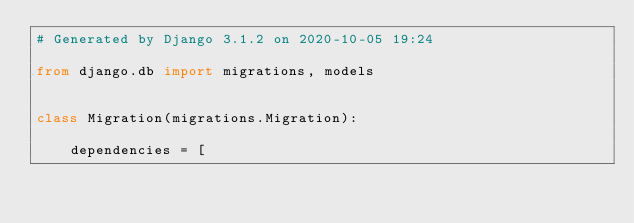Convert code to text. <code><loc_0><loc_0><loc_500><loc_500><_Python_># Generated by Django 3.1.2 on 2020-10-05 19:24

from django.db import migrations, models


class Migration(migrations.Migration):

    dependencies = [</code> 